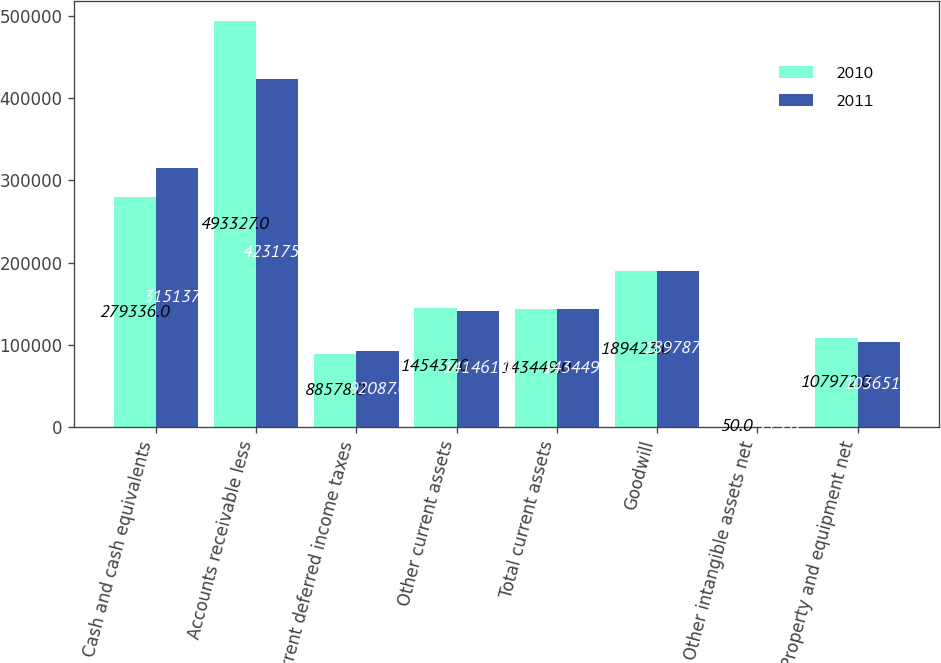Convert chart to OTSL. <chart><loc_0><loc_0><loc_500><loc_500><stacked_bar_chart><ecel><fcel>Cash and cash equivalents<fcel>Accounts receivable less<fcel>Current deferred income taxes<fcel>Other current assets<fcel>Total current assets<fcel>Goodwill<fcel>Other intangible assets net<fcel>Property and equipment net<nl><fcel>2010<fcel>279336<fcel>493327<fcel>88578<fcel>145437<fcel>143449<fcel>189423<fcel>50<fcel>107972<nl><fcel>2011<fcel>315137<fcel>423175<fcel>92087<fcel>141461<fcel>143449<fcel>189787<fcel>219<fcel>103651<nl></chart> 